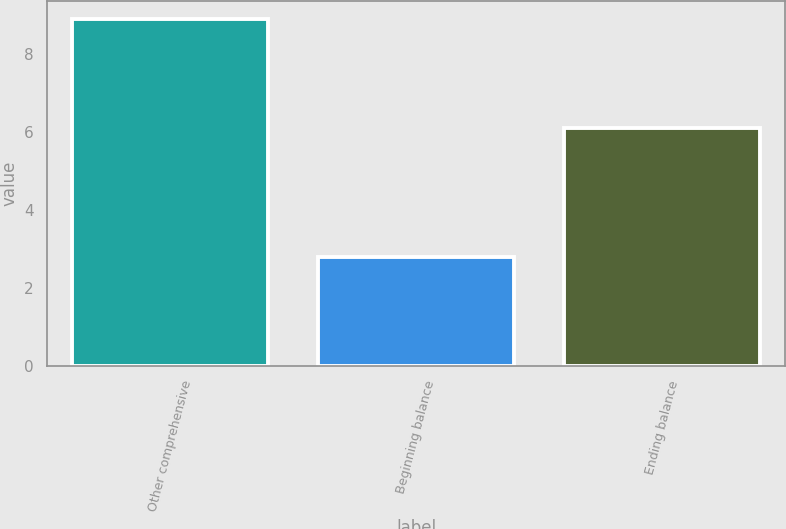Convert chart. <chart><loc_0><loc_0><loc_500><loc_500><bar_chart><fcel>Other comprehensive<fcel>Beginning balance<fcel>Ending balance<nl><fcel>8.9<fcel>2.8<fcel>6.1<nl></chart> 